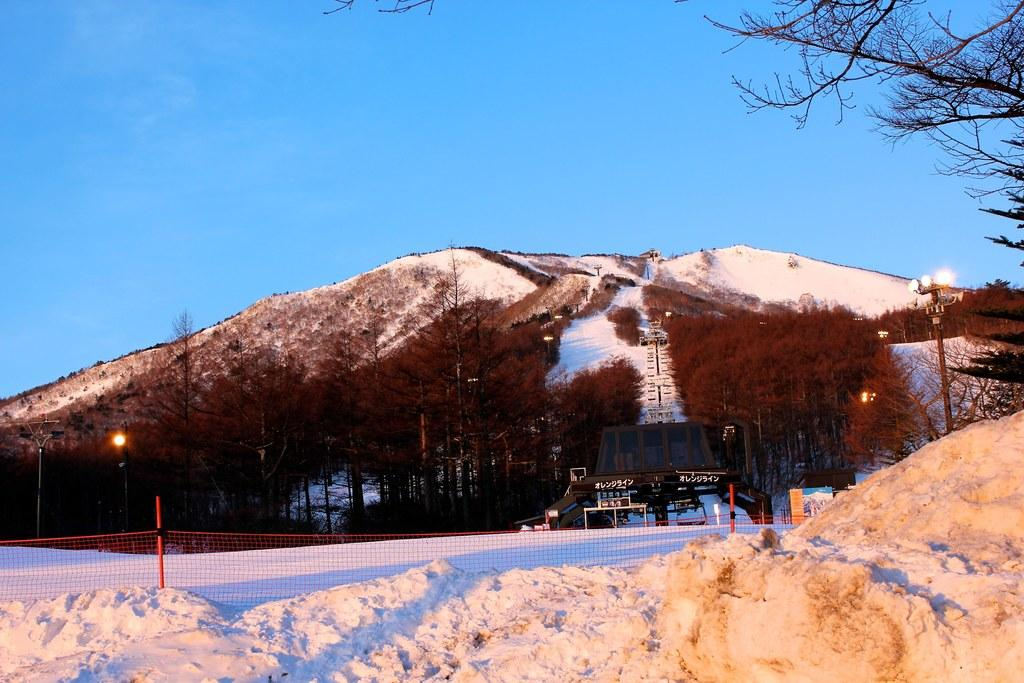What is the main feature in the foreground of the picture? There is snow in the foreground of the picture. What can be seen in the center of the picture? There are trees, lights, a construction, and a hill in the center of the picture. Are there any trees visible on the right side of the picture? Yes, there are trees on the right side of the picture. How would you describe the weather based on the sky in the picture? The sky is sunny in the picture. What idea does the queen have about the ongoing operation in the picture? There is no queen or operation present in the image; it features snow, trees, lights, a construction, and a hill. 